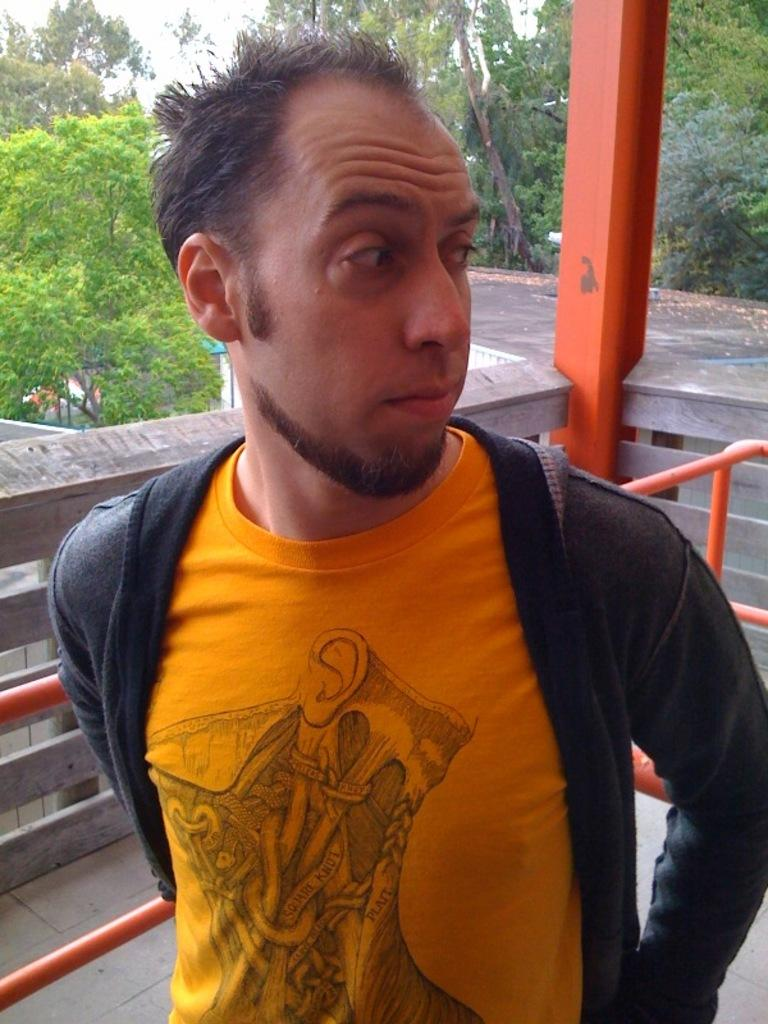What is the main subject of the image? There is a man standing in the image. What can be seen in the background of the image? There are iron rods, a wall, trees, and the sky visible in the background of the image. What type of lipstick is the man wearing in the image? The man is not wearing any lipstick in the image. What kind of bait is being used by the man in the image? There is no bait present in the image; it features a man standing with a background of iron rods, a wall, trees, and the sky. 